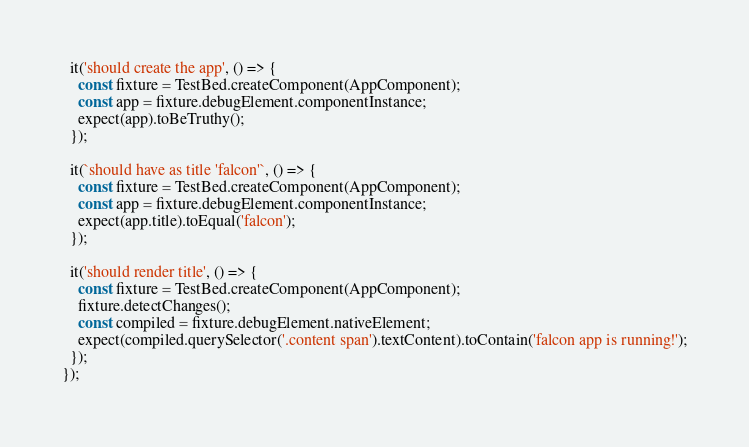<code> <loc_0><loc_0><loc_500><loc_500><_TypeScript_>  it('should create the app', () => {
    const fixture = TestBed.createComponent(AppComponent);
    const app = fixture.debugElement.componentInstance;
    expect(app).toBeTruthy();
  });

  it(`should have as title 'falcon'`, () => {
    const fixture = TestBed.createComponent(AppComponent);
    const app = fixture.debugElement.componentInstance;
    expect(app.title).toEqual('falcon');
  });

  it('should render title', () => {
    const fixture = TestBed.createComponent(AppComponent);
    fixture.detectChanges();
    const compiled = fixture.debugElement.nativeElement;
    expect(compiled.querySelector('.content span').textContent).toContain('falcon app is running!');
  });
});
</code> 